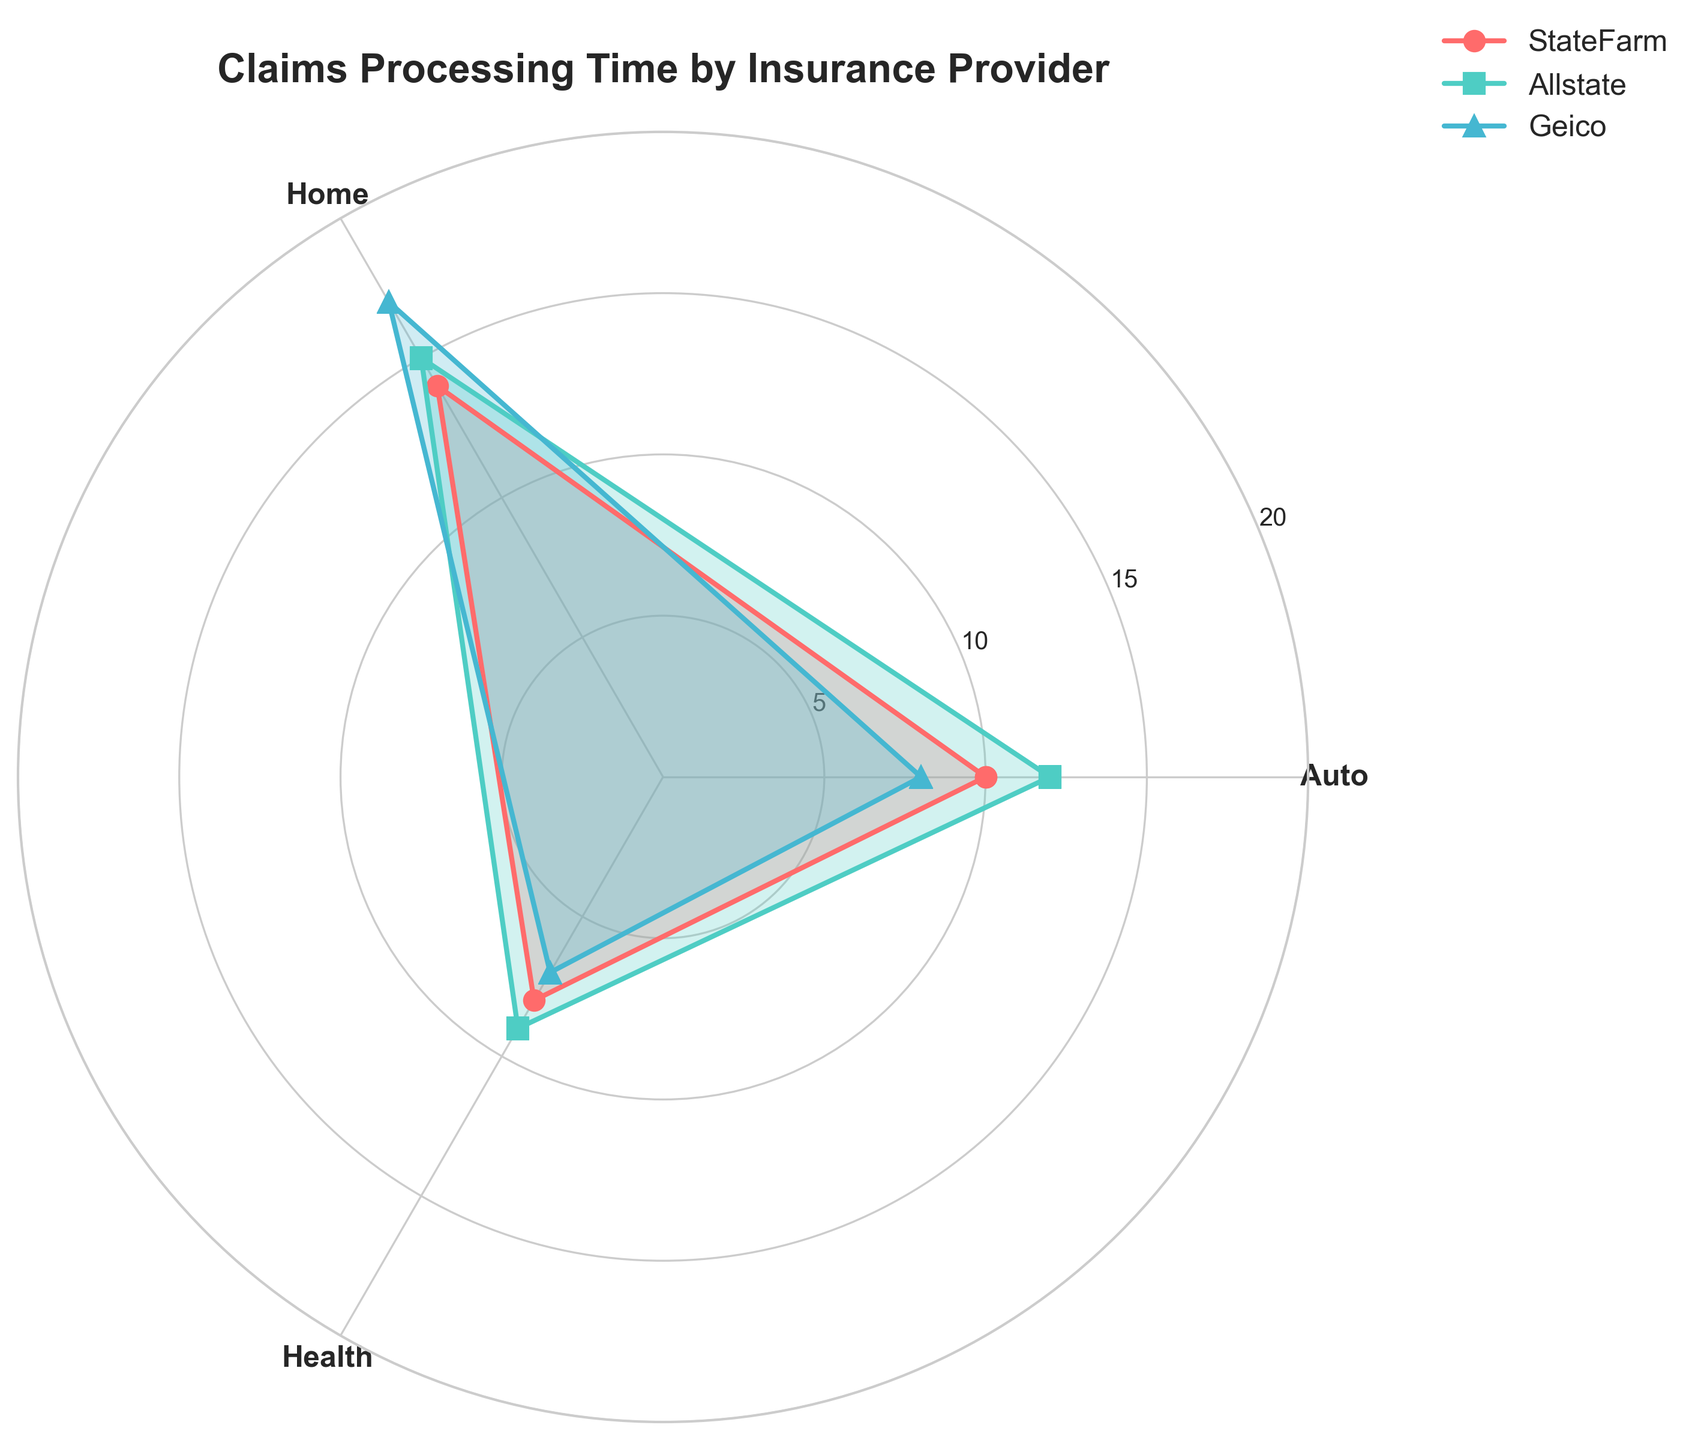Which insurance provider has the shortest processing time for Health claims? By observing the radar chart, locate the "Health" label on the chart. Then, look at the lines converging at this point to determine which insurance provider's line is the closest to the center, indicating the shortest processing time.
Answer: Geico What is the average processing time for Home claims across the three providers shown? Identify the "Home" processing times for StateFarm (14 days), Allstate (15 days), and Geico (17 days). Sum these values and then divide by the number of providers (3). The calculation is (14 + 15 + 17) / 3.
Answer: 15.33 days Which insurance provider has the most variability in their claims processing times, and how is this determined? Analyze the spread or range of each insurance provider's processing times across different claim types. The more variability means the larger difference between the highest and lowest values within a provider.
Answer: Geico Are there any claim types where all three insurance providers have the same processing time? Examine each radial axis for overlapping points from all providers. Observation indicates that no claim types have identical processing times across all providers.
Answer: No Between StateFarm and Progressive, which provider is faster for Auto claims, and by how much? Compare the "Auto" processing time values for StateFarm (10 days) and Progressive (11 days). Calculate the difference by subtracting the smaller value (StateFarm) from the larger value (Progressive).
Answer: StateFarm by 1 day What can be inferred about the relative performance of the insurance providers in processing Auto claims? Assess the positions of the points at the "Auto" label. Geico is closest to the center (8 days), followed by StateFarm (10 days), Progressive (11 days), and Allstate (12 days). Therefore, Geico processes Auto claims the fastest among the providers.
Answer: Geico is fastest How does Allstate's processing time for Auto claims compare to their processing time for Health claims? Look at the two points for Allstate: Auto (12 days) and Health (9 days). Determine the difference by subtracting the processing time for Health claims from the processing time for Auto claims.
Answer: Allstate's Auto claims are 3 days longer Is there a pattern in terms of which provider excels in processing the fastest claims in multiple claim types? Analyze which provider has the lowest processing time for each claim type: Auto (Geico), Home (StateFarm), and Health (Geico). Geico appears twice in the lower processing times, suggesting it generally processes claims faster across multiple claim types.
Answer: Geico excels in multiple types 